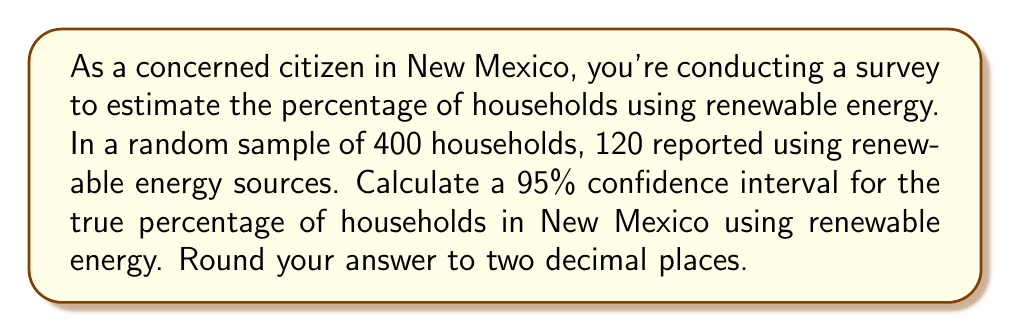Can you answer this question? Let's approach this step-by-step:

1) First, we need to calculate the sample proportion:
   $\hat{p} = \frac{\text{number of successes}}{\text{sample size}} = \frac{120}{400} = 0.3$ or 30%

2) The formula for the confidence interval is:
   $$\hat{p} \pm z^* \sqrt{\frac{\hat{p}(1-\hat{p})}{n}}$$
   where $z^*$ is the critical value for the desired confidence level.

3) For a 95% confidence interval, $z^* = 1.96$

4) Now, let's substitute our values:
   $n = 400$
   $\hat{p} = 0.3$

5) Calculate the standard error:
   $$SE = \sqrt{\frac{\hat{p}(1-\hat{p})}{n}} = \sqrt{\frac{0.3(1-0.3)}{400}} = \sqrt{\frac{0.21}{400}} = 0.0229$$

6) Now we can calculate the margin of error:
   $$ME = z^* \times SE = 1.96 \times 0.0229 = 0.0449$$

7) Finally, we can construct the confidence interval:
   $$0.3 \pm 0.0449$$
   
   Lower bound: $0.3 - 0.0449 = 0.2551$
   Upper bound: $0.3 + 0.0449 = 0.3449$

8) Rounding to two decimal places:
   (0.26, 0.34) or (26%, 34%)
Answer: (0.26, 0.34) or (26%, 34%) 